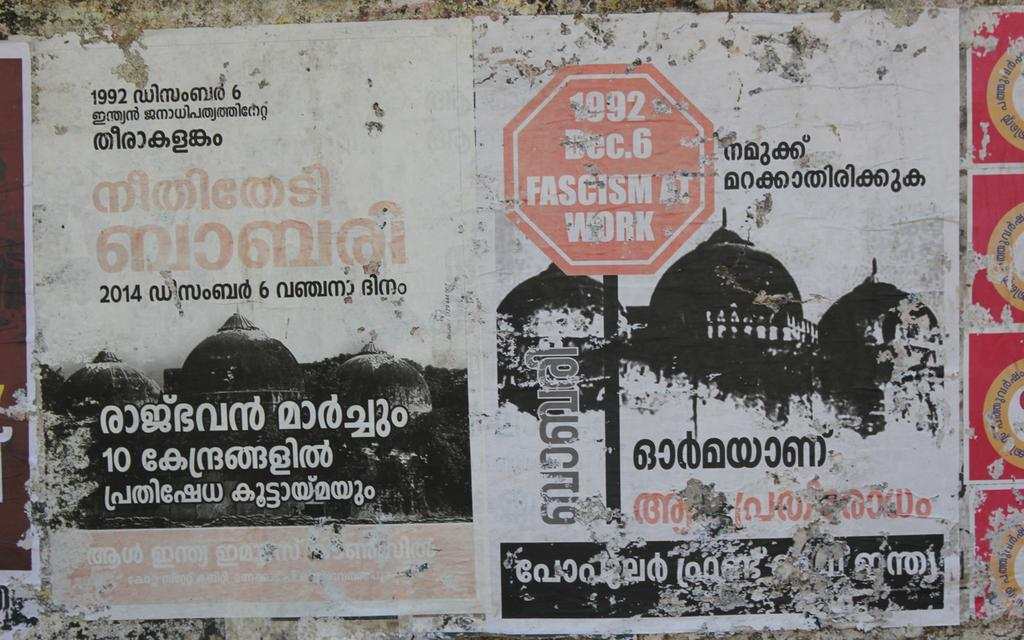<image>
Relay a brief, clear account of the picture shown. A wall containing advertising in a foreign language with the dates 1992 and 2014. 